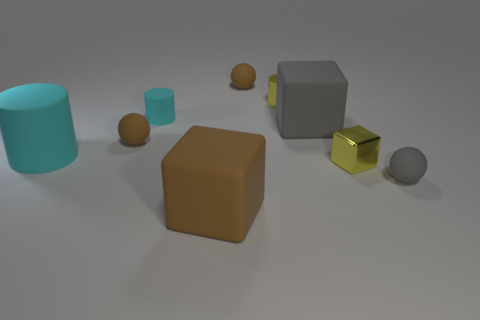Subtract 1 cylinders. How many cylinders are left? 2 Subtract all cylinders. How many objects are left? 6 Subtract all tiny purple rubber objects. Subtract all small rubber objects. How many objects are left? 5 Add 7 yellow cylinders. How many yellow cylinders are left? 8 Add 7 large blue blocks. How many large blue blocks exist? 7 Subtract 0 gray cylinders. How many objects are left? 9 